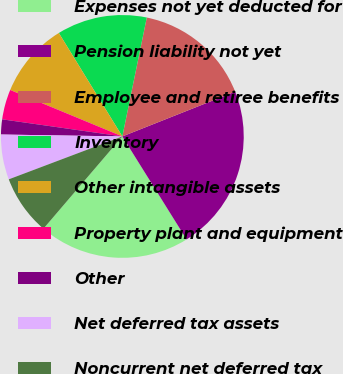<chart> <loc_0><loc_0><loc_500><loc_500><pie_chart><fcel>Expenses not yet deducted for<fcel>Pension liability not yet<fcel>Employee and retiree benefits<fcel>Inventory<fcel>Other intangible assets<fcel>Property plant and equipment<fcel>Other<fcel>Net deferred tax assets<fcel>Noncurrent net deferred tax<nl><fcel>20.14%<fcel>22.14%<fcel>15.76%<fcel>11.99%<fcel>9.99%<fcel>4.0%<fcel>2.0%<fcel>6.0%<fcel>7.99%<nl></chart> 